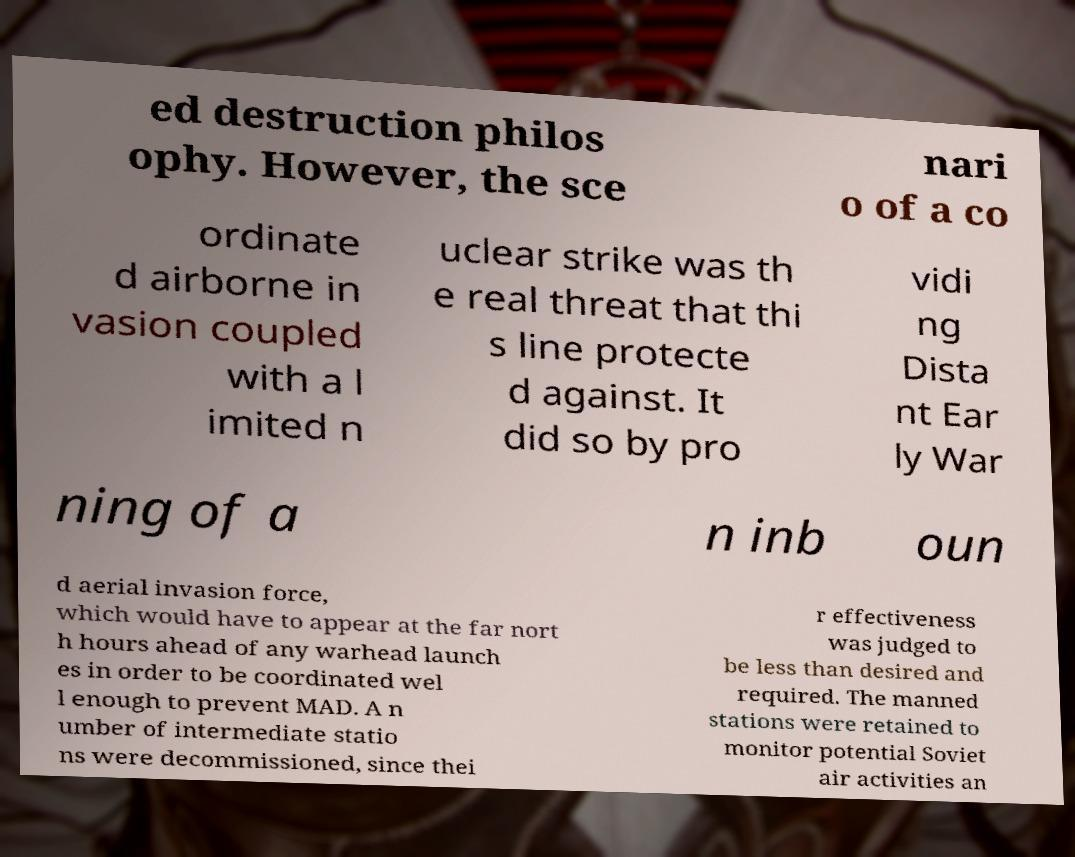Please identify and transcribe the text found in this image. ed destruction philos ophy. However, the sce nari o of a co ordinate d airborne in vasion coupled with a l imited n uclear strike was th e real threat that thi s line protecte d against. It did so by pro vidi ng Dista nt Ear ly War ning of a n inb oun d aerial invasion force, which would have to appear at the far nort h hours ahead of any warhead launch es in order to be coordinated wel l enough to prevent MAD. A n umber of intermediate statio ns were decommissioned, since thei r effectiveness was judged to be less than desired and required. The manned stations were retained to monitor potential Soviet air activities an 